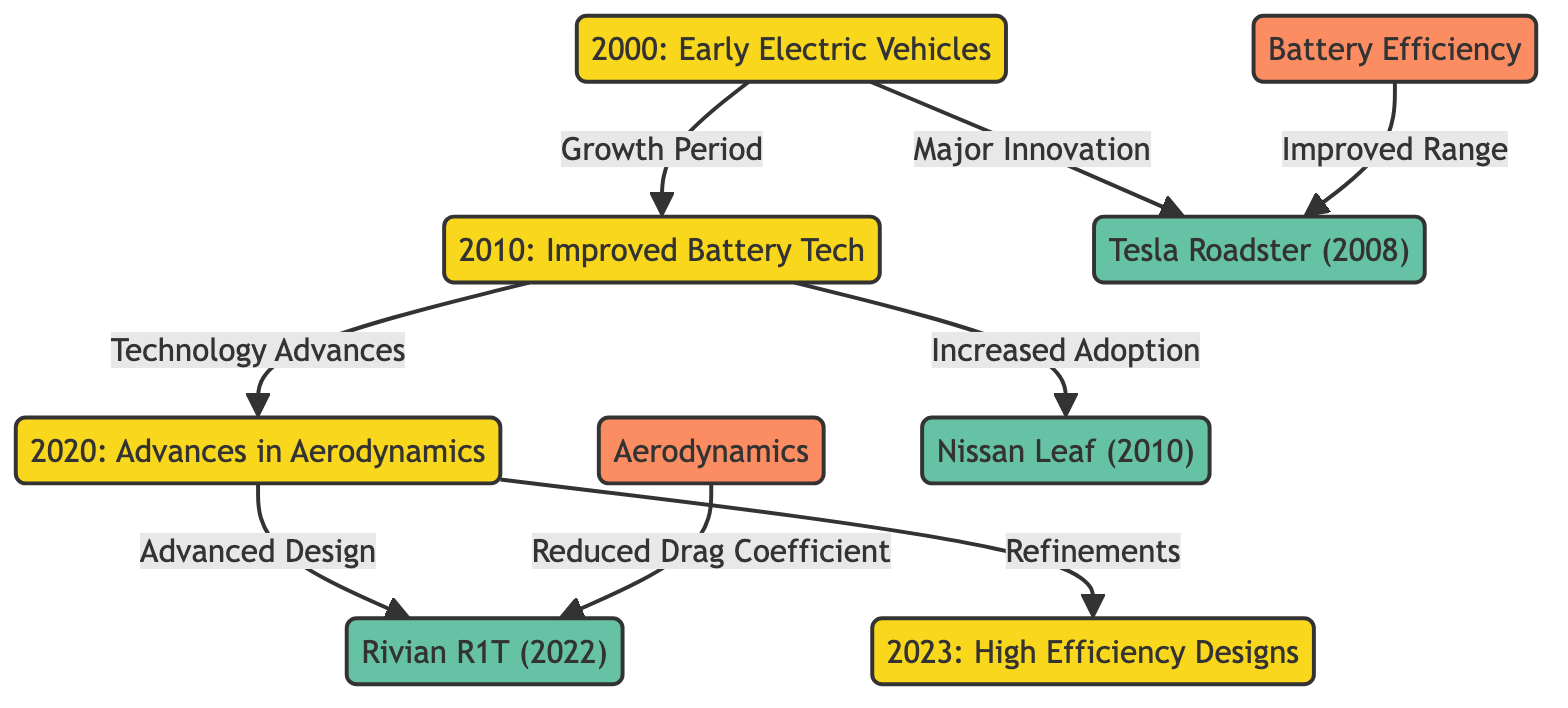What car was introduced in 2008? The diagram highlights that the Tesla Roadster is connected to the year 2000, indicating its introduction as a major innovation in electric vehicles during that period.
Answer: Tesla Roadster What feature was emphasized with the Rivian R1T? The diagram shows an arrow from the "Aerodynamics" feature node pointing to the Rivian R1T, indicating that its design focuses on reducing drag coefficient for improved efficiency.
Answer: Reduced Drag Coefficient Which year showcases significant advances in battery technology? The chart explicitly points from the year 2010 to the "Improved Battery Tech," marking this year as significant for technological advancements in battery efficiency within electric vehicles.
Answer: 2010 How many main car models are featured in this diagram? The diagram lists three car nodes: Tesla Roadster, Nissan Leaf, and Rivian R1T. By counting these nodes, we find a total of three noteworthy models emphasized in the timeline.
Answer: 3 What is the relationship between the years 2010 and 2020? The diagram indicates a direct flow from 2010 to 2020, labeled as "Technology Advances," signifying that developments in the 2010s led to notable innovations and advancements during the subsequent decade.
Answer: Technology Advances Which electric vehicle was linked with improved range in its design? The diagram connects the "Battery Efficiency" node to the Tesla Roadster, suggesting that improved range was a critical aspect attributed to its battery technology development.
Answer: Tesla Roadster What was the primary design focus of electric vehicles by 2023? An arrow trails from 2020 to the year 2023, labeled "Refinements," indicating that by this time, electric vehicle design has primarily directed its emphasis toward achieving high efficiency.
Answer: High Efficiency Designs Which year marks the introduction of the Nissan Leaf? The diagram clearly shows that the Nissan Leaf is connected to 2010, denoting it as the year when this particular electric vehicle model was introduced.
Answer: 2010 What significant trend began with early electric vehicles in 2000? The flowchart specifies that early electric vehicles marked a "Major Innovation" point, implying that the trend highlighted from 2000 indicates a vital leap forward in electric vehicle design.
Answer: Major Innovation 